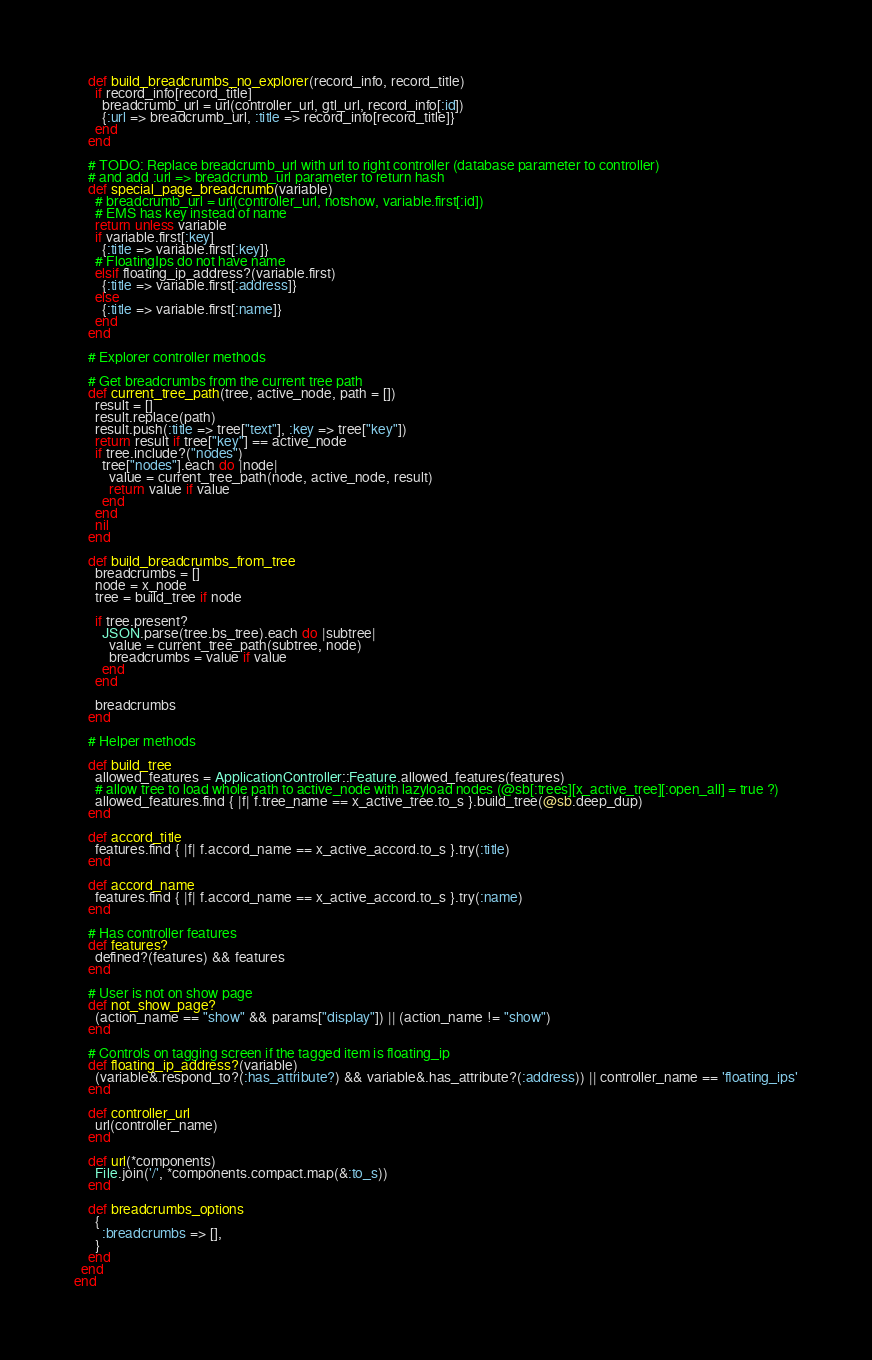Convert code to text. <code><loc_0><loc_0><loc_500><loc_500><_Ruby_>
    def build_breadcrumbs_no_explorer(record_info, record_title)
      if record_info[record_title]
        breadcrumb_url = url(controller_url, gtl_url, record_info[:id])
        {:url => breadcrumb_url, :title => record_info[record_title]}
      end
    end

    # TODO: Replace breadcrumb_url with url to right controller (database parameter to controller)
    # and add :url => breadcrumb_url parameter to return hash
    def special_page_breadcrumb(variable)
      # breadcrumb_url = url(controller_url, notshow, variable.first[:id])
      # EMS has key instead of name
      return unless variable
      if variable.first[:key]
        {:title => variable.first[:key]}
      # FloatingIps do not have name
      elsif floating_ip_address?(variable.first)
        {:title => variable.first[:address]}
      else
        {:title => variable.first[:name]}
      end
    end

    # Explorer controller methods

    # Get breadcrumbs from the current tree path
    def current_tree_path(tree, active_node, path = [])
      result = []
      result.replace(path)
      result.push(:title => tree["text"], :key => tree["key"])
      return result if tree["key"] == active_node
      if tree.include?("nodes")
        tree["nodes"].each do |node|
          value = current_tree_path(node, active_node, result)
          return value if value
        end
      end
      nil
    end

    def build_breadcrumbs_from_tree
      breadcrumbs = []
      node = x_node
      tree = build_tree if node

      if tree.present?
        JSON.parse(tree.bs_tree).each do |subtree|
          value = current_tree_path(subtree, node)
          breadcrumbs = value if value
        end
      end

      breadcrumbs
    end

    # Helper methods

    def build_tree
      allowed_features = ApplicationController::Feature.allowed_features(features)
      # allow tree to load whole path to active_node with lazyload nodes (@sb[:trees][x_active_tree][:open_all] = true ?)
      allowed_features.find { |f| f.tree_name == x_active_tree.to_s }.build_tree(@sb.deep_dup)
    end

    def accord_title
      features.find { |f| f.accord_name == x_active_accord.to_s }.try(:title)
    end

    def accord_name
      features.find { |f| f.accord_name == x_active_accord.to_s }.try(:name)
    end

    # Has controller features
    def features?
      defined?(features) && features
    end

    # User is not on show page
    def not_show_page?
      (action_name == "show" && params["display"]) || (action_name != "show")
    end

    # Controls on tagging screen if the tagged item is floating_ip
    def floating_ip_address?(variable)
      (variable&.respond_to?(:has_attribute?) && variable&.has_attribute?(:address)) || controller_name == 'floating_ips'
    end

    def controller_url
      url(controller_name)
    end

    def url(*components)
      File.join('/', *components.compact.map(&:to_s))
    end

    def breadcrumbs_options
      {
        :breadcrumbs => [],
      }
    end
  end
end
</code> 